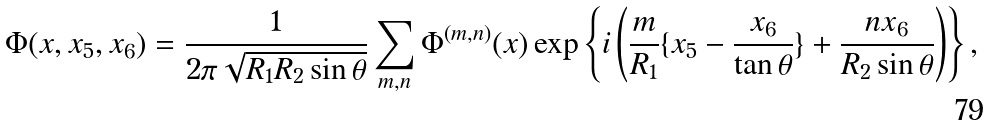Convert formula to latex. <formula><loc_0><loc_0><loc_500><loc_500>\Phi ( x , x _ { 5 } , x _ { 6 } ) = \frac { 1 } { 2 \pi \sqrt { R _ { 1 } R _ { 2 } \sin \theta } } \sum _ { m , n } \Phi ^ { ( m , n ) } ( x ) \exp \left \{ i \left ( \frac { m } { R _ { 1 } } \{ x _ { 5 } - \frac { x _ { 6 } } { \tan \theta } \} + \frac { n x _ { 6 } } { R _ { 2 } \sin \theta } \right ) \right \} ,</formula> 